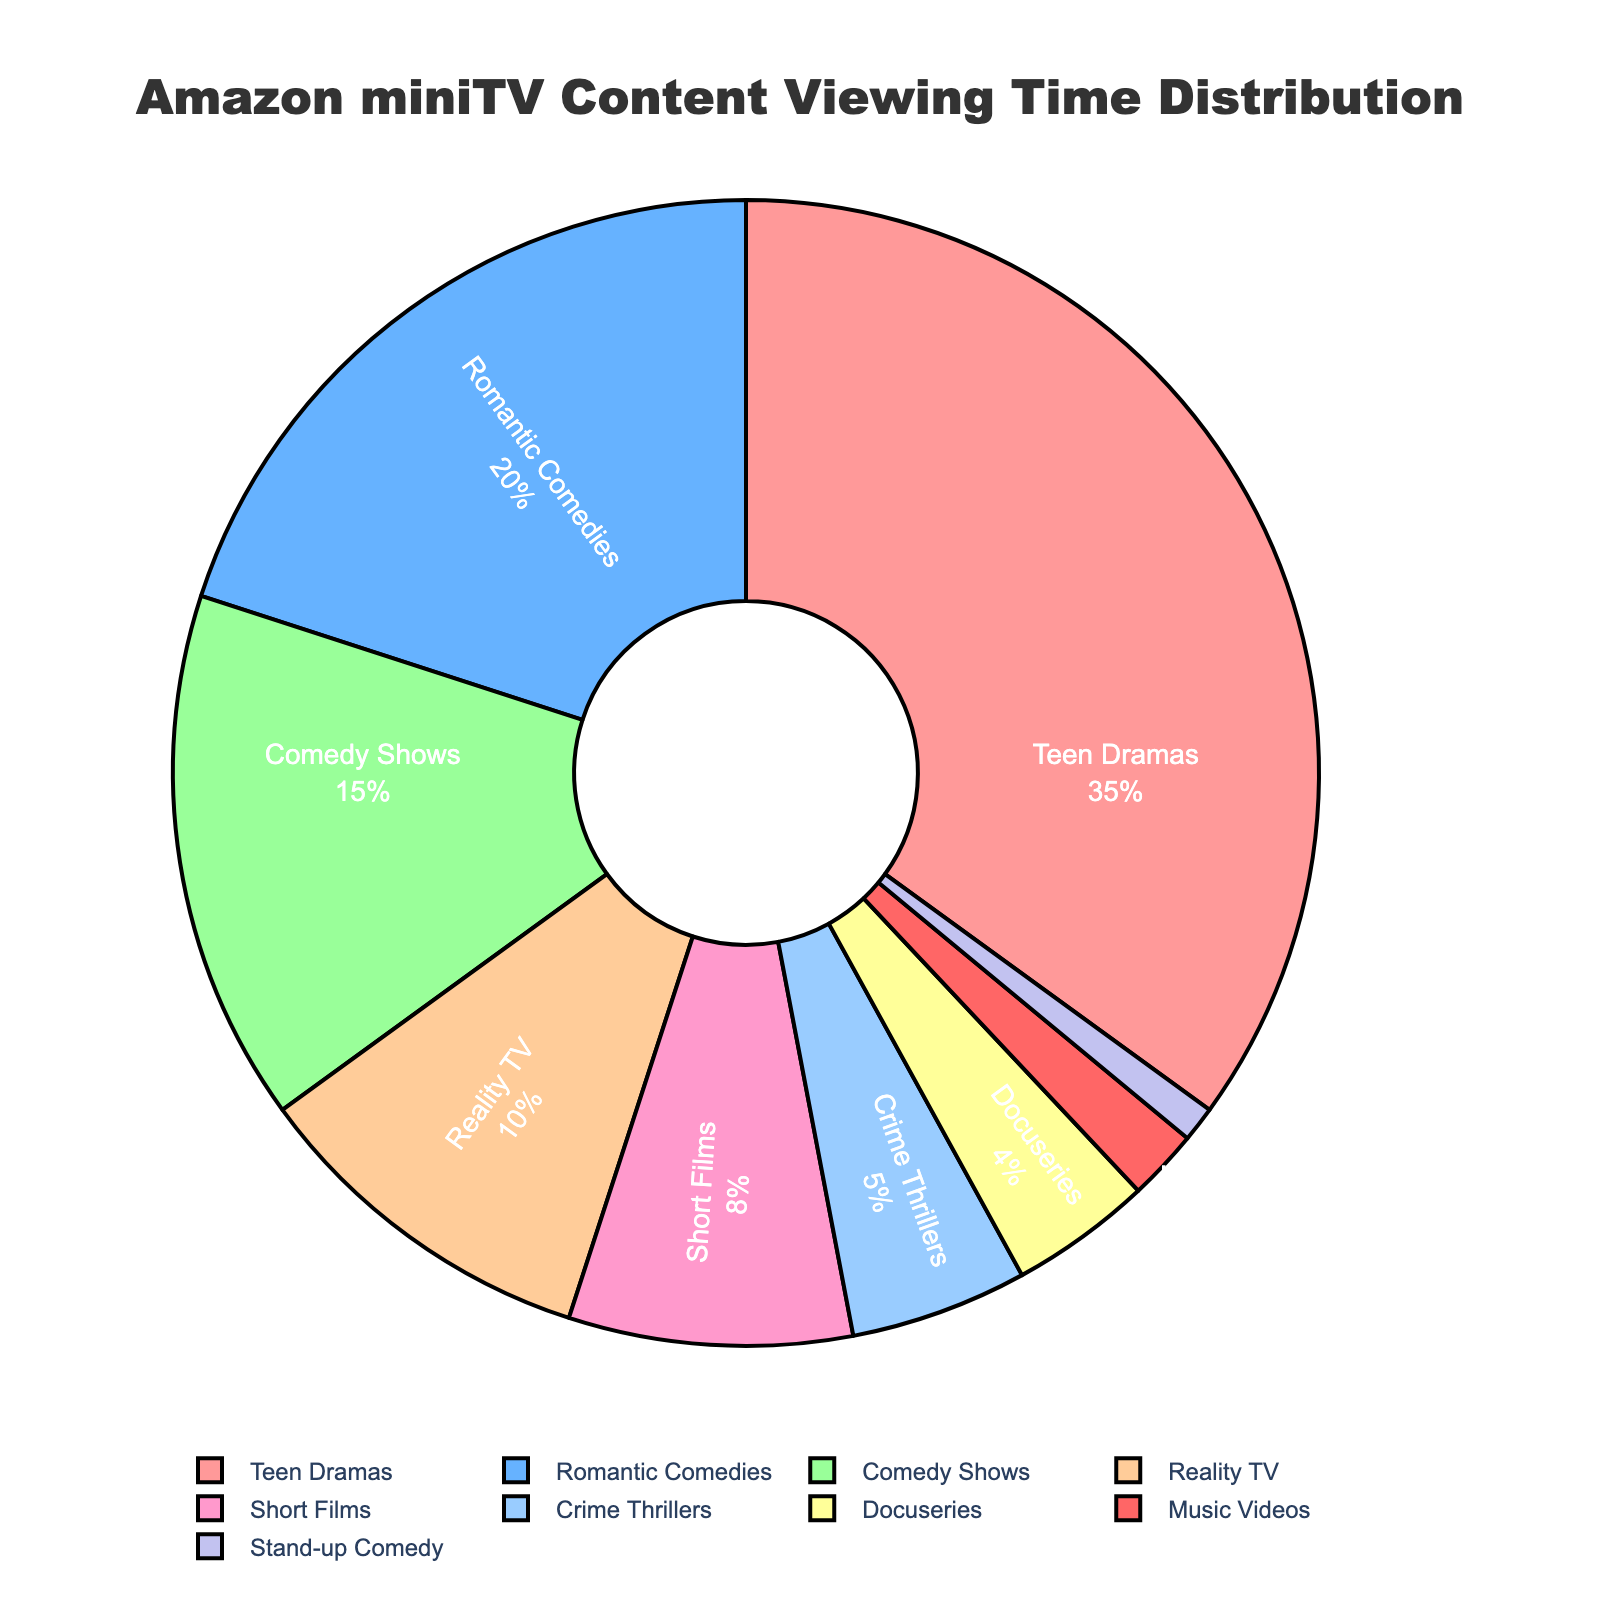Which category has the highest viewing time percentage? From the pie chart, the 'Teen Dramas' slice is the largest, indicating it has the highest percentage of viewing time.
Answer: Teen Dramas What is the total viewing time percentage for non-dramatic genres (i.e., excluding 'Teen Dramas')? Exclude Teen Dramas (35%) from the total 100%. Add the remaining percentages: 20 + 15 + 10 + 8 + 5 + 4 + 2 + 1 = 65%.
Answer: 65% How much greater is the viewing time percentage of 'Teen Dramas' compared to 'Comedy Shows'? 'Teen Dramas' have a viewing time of 35% and 'Comedy Shows' have 15%. The difference is 35 - 15 = 20%.
Answer: 20% Which categories have a combined viewing time percentage greater than 'Teen Dramas'? Add the percentages of different combinations and compare. 'Teen Dramas' are 35%, so combinations should be greater than 35%. For example, 'Romantic Comedies' (20%) + 'Comedy Shows' (15%) = 35% does not qualify. Try 'Romantic Comedies' (20%) + 'Reality TV' (10%) + 'Short Films' (8%) = 38%.
Answer: Romantic Comedies, Reality TV, Short Films Which category occupies the smallest portion of the pie chart? From the chart, the smallest slice is 'Stand-up Comedy' with a 1% viewing time percentage.
Answer: Stand-up Comedy What is the average viewing time percentage of the categories with a percentage above 5%? Categories above 5% are 'Teen Dramas' (35%), 'Romantic Comedies' (20%), 'Comedy Shows' (15%), 'Reality TV' (10%), 'Short Films' (8%). Average is (35 + 20 + 15 + 10 + 8) / 5 = 88 / 5 = 17.6%.
Answer: 17.6% How does the viewing time percentage of 'Docuseries' compare to that of 'Crime Thrillers'? 'Docuseries' have a 4% viewing time and 'Crime Thrillers' have 5%. Since 4% < 5%, 'Docuseries' have a lower viewing time percentage.
Answer: Docuseries is lower 